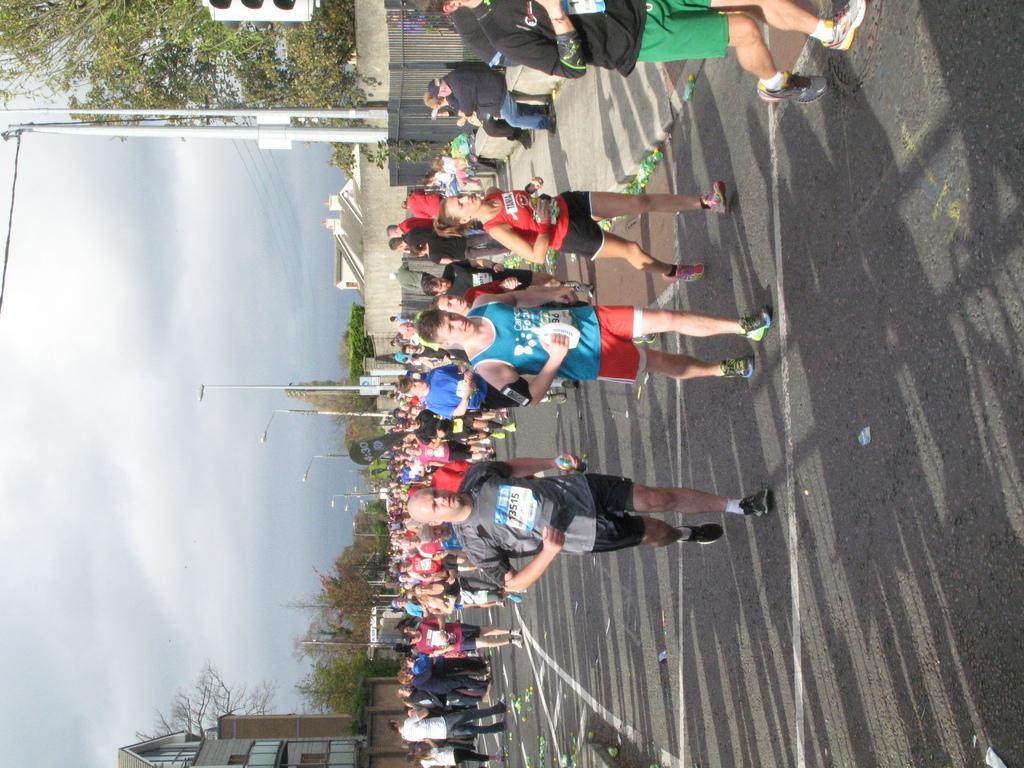In one or two sentences, can you explain what this image depicts? In the center of the image a group of people are running. At the top of the image we can see wall, poles, trees, traffic light are there. In the center of the image an electric light pole is there. At the bottom of the image building is there. On the right side of the image road is there. On the left side of the image clouds are present in the sky. 